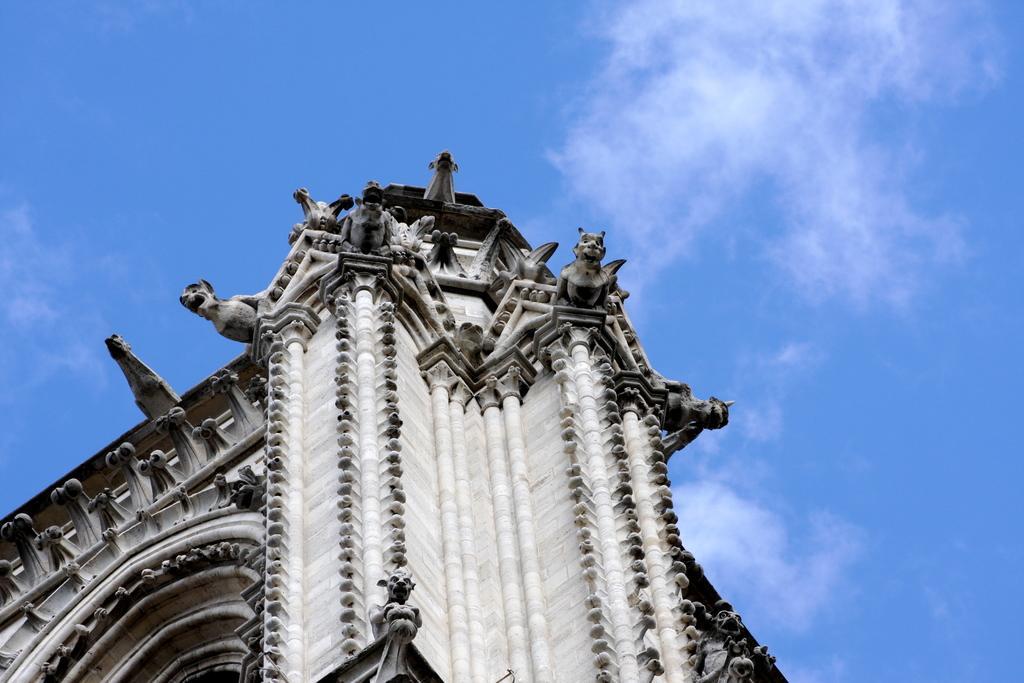Could you give a brief overview of what you see in this image? In this image there is a monument. On it there are statues of animals. The sky is cloudy. 